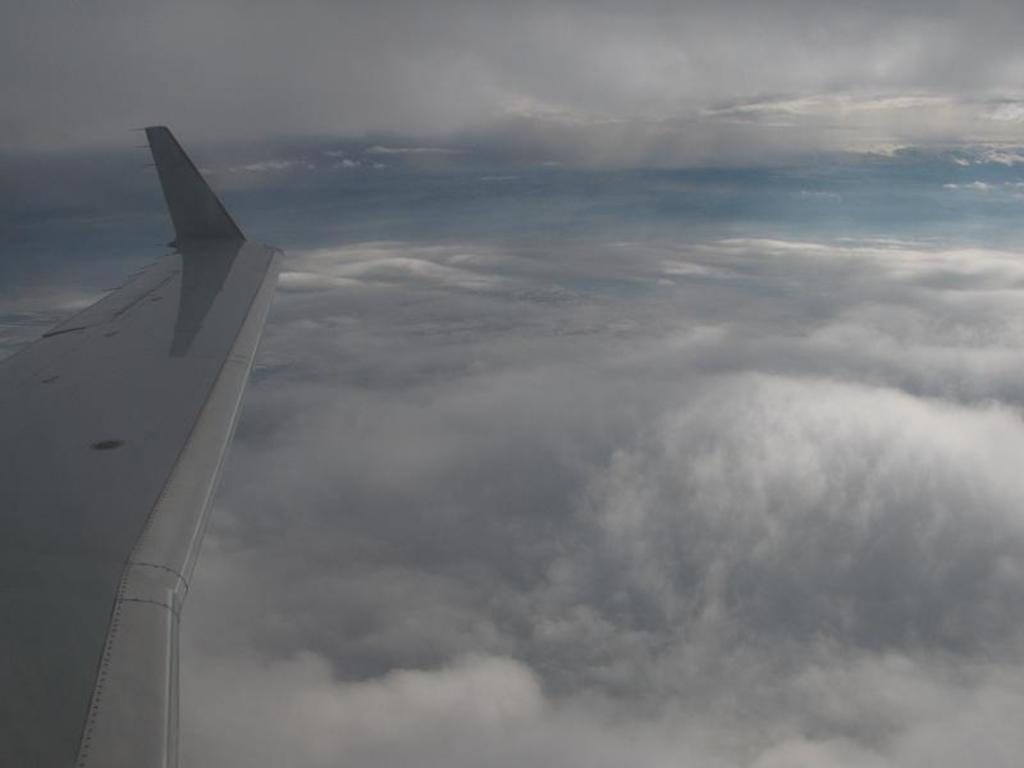What is the main subject of the image? The main subject of the image is an airplane. Can you describe the position of the airplane in the image? The airplane is in the air in the image. What can be seen in the background of the image? There are clouds in the sky in the background of the image. What type of jewel is being riddled about in the image? There is no jewel or riddle present in the image; it features an airplane in the air with clouds in the background. 